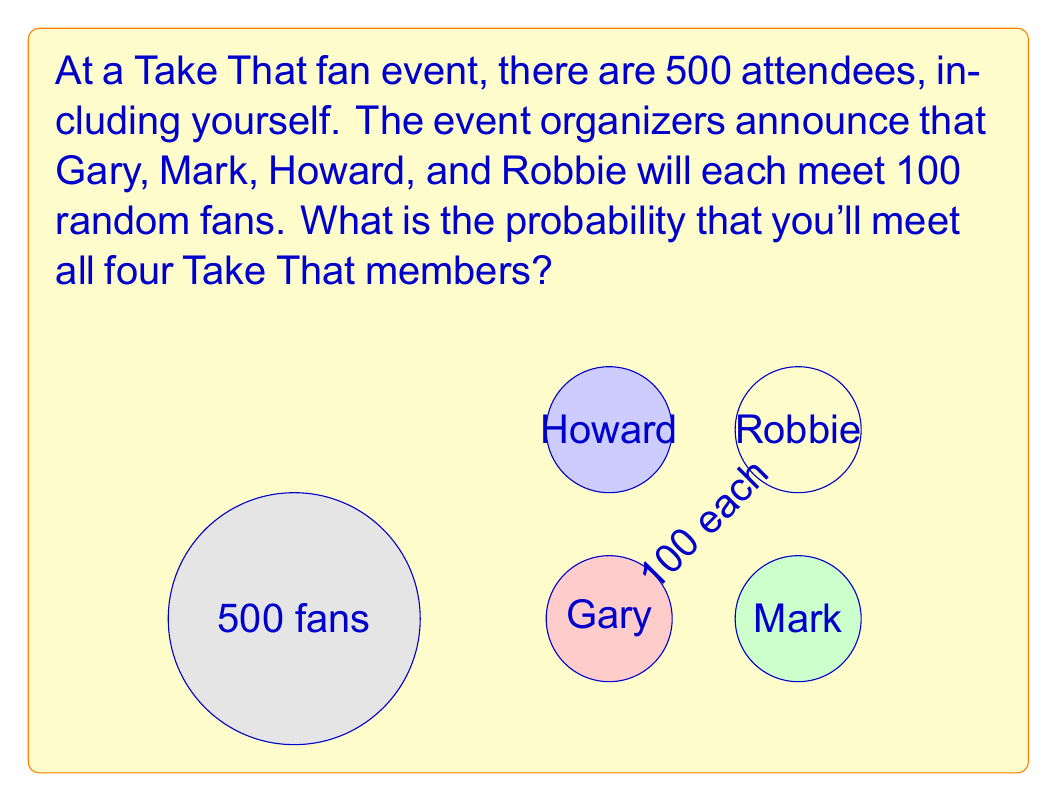Provide a solution to this math problem. Let's approach this step-by-step:

1) For each member, the probability of meeting them is:
   $P(\text{meeting one member}) = \frac{100}{500} = \frac{1}{5}$

2) The probability of meeting all four members is the product of the individual probabilities, as these are independent events:

   $P(\text{meeting all}) = P(\text{Gary}) \times P(\text{Mark}) \times P(\text{Howard}) \times P(\text{Robbie})$

3) Substituting the probabilities:

   $P(\text{meeting all}) = \frac{1}{5} \times \frac{1}{5} \times \frac{1}{5} \times \frac{1}{5}$

4) Simplifying:

   $P(\text{meeting all}) = (\frac{1}{5})^4 = \frac{1}{625}$

5) To express this as a percentage:

   $\frac{1}{625} \times 100\% = 0.16\%$

Therefore, the probability of meeting all four Take That members is $\frac{1}{625}$ or approximately 0.16%.
Answer: $\frac{1}{625}$ 